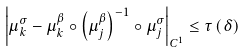<formula> <loc_0><loc_0><loc_500><loc_500>\left | \mu _ { k } ^ { \sigma } - \mu _ { k } ^ { \beta } \circ \left ( \mu _ { j } ^ { \beta } \right ) ^ { - 1 } \circ \mu _ { j } ^ { \sigma } \right | _ { C ^ { 1 } } \leq \tau \left ( \delta \right )</formula> 